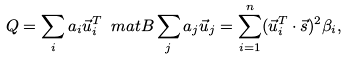<formula> <loc_0><loc_0><loc_500><loc_500>Q = \sum _ { i } a _ { i } \vec { u } _ { i } ^ { T } \ m a t { B } \sum _ { j } a _ { j } \vec { u } _ { j } = \sum _ { i = 1 } ^ { n } ( \vec { u } _ { i } ^ { T } \cdot \vec { s } ) ^ { 2 } \beta _ { i } ,</formula> 